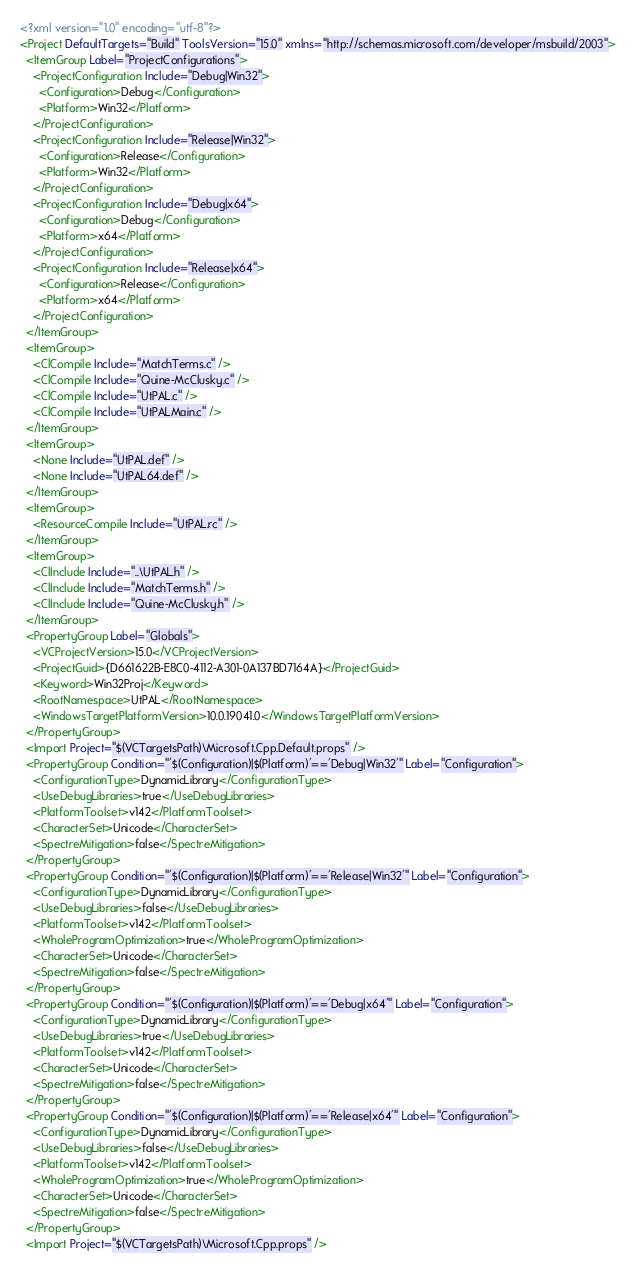Convert code to text. <code><loc_0><loc_0><loc_500><loc_500><_XML_><?xml version="1.0" encoding="utf-8"?>
<Project DefaultTargets="Build" ToolsVersion="15.0" xmlns="http://schemas.microsoft.com/developer/msbuild/2003">
  <ItemGroup Label="ProjectConfigurations">
    <ProjectConfiguration Include="Debug|Win32">
      <Configuration>Debug</Configuration>
      <Platform>Win32</Platform>
    </ProjectConfiguration>
    <ProjectConfiguration Include="Release|Win32">
      <Configuration>Release</Configuration>
      <Platform>Win32</Platform>
    </ProjectConfiguration>
    <ProjectConfiguration Include="Debug|x64">
      <Configuration>Debug</Configuration>
      <Platform>x64</Platform>
    </ProjectConfiguration>
    <ProjectConfiguration Include="Release|x64">
      <Configuration>Release</Configuration>
      <Platform>x64</Platform>
    </ProjectConfiguration>
  </ItemGroup>
  <ItemGroup>
    <ClCompile Include="MatchTerms.c" />
    <ClCompile Include="Quine-McClusky.c" />
    <ClCompile Include="UtPAL.c" />
    <ClCompile Include="UtPALMain.c" />
  </ItemGroup>
  <ItemGroup>
    <None Include="UtPAL.def" />
    <None Include="UtPAL64.def" />
  </ItemGroup>
  <ItemGroup>
    <ResourceCompile Include="UtPAL.rc" />
  </ItemGroup>
  <ItemGroup>
    <ClInclude Include="..\UtPAL.h" />
    <ClInclude Include="MatchTerms.h" />
    <ClInclude Include="Quine-McClusky.h" />
  </ItemGroup>
  <PropertyGroup Label="Globals">
    <VCProjectVersion>15.0</VCProjectVersion>
    <ProjectGuid>{D661622B-E8C0-4112-A301-0A137BD7164A}</ProjectGuid>
    <Keyword>Win32Proj</Keyword>
    <RootNamespace>UtPAL</RootNamespace>
    <WindowsTargetPlatformVersion>10.0.19041.0</WindowsTargetPlatformVersion>
  </PropertyGroup>
  <Import Project="$(VCTargetsPath)\Microsoft.Cpp.Default.props" />
  <PropertyGroup Condition="'$(Configuration)|$(Platform)'=='Debug|Win32'" Label="Configuration">
    <ConfigurationType>DynamicLibrary</ConfigurationType>
    <UseDebugLibraries>true</UseDebugLibraries>
    <PlatformToolset>v142</PlatformToolset>
    <CharacterSet>Unicode</CharacterSet>
    <SpectreMitigation>false</SpectreMitigation>
  </PropertyGroup>
  <PropertyGroup Condition="'$(Configuration)|$(Platform)'=='Release|Win32'" Label="Configuration">
    <ConfigurationType>DynamicLibrary</ConfigurationType>
    <UseDebugLibraries>false</UseDebugLibraries>
    <PlatformToolset>v142</PlatformToolset>
    <WholeProgramOptimization>true</WholeProgramOptimization>
    <CharacterSet>Unicode</CharacterSet>
    <SpectreMitigation>false</SpectreMitigation>
  </PropertyGroup>
  <PropertyGroup Condition="'$(Configuration)|$(Platform)'=='Debug|x64'" Label="Configuration">
    <ConfigurationType>DynamicLibrary</ConfigurationType>
    <UseDebugLibraries>true</UseDebugLibraries>
    <PlatformToolset>v142</PlatformToolset>
    <CharacterSet>Unicode</CharacterSet>
    <SpectreMitigation>false</SpectreMitigation>
  </PropertyGroup>
  <PropertyGroup Condition="'$(Configuration)|$(Platform)'=='Release|x64'" Label="Configuration">
    <ConfigurationType>DynamicLibrary</ConfigurationType>
    <UseDebugLibraries>false</UseDebugLibraries>
    <PlatformToolset>v142</PlatformToolset>
    <WholeProgramOptimization>true</WholeProgramOptimization>
    <CharacterSet>Unicode</CharacterSet>
    <SpectreMitigation>false</SpectreMitigation>
  </PropertyGroup>
  <Import Project="$(VCTargetsPath)\Microsoft.Cpp.props" /></code> 